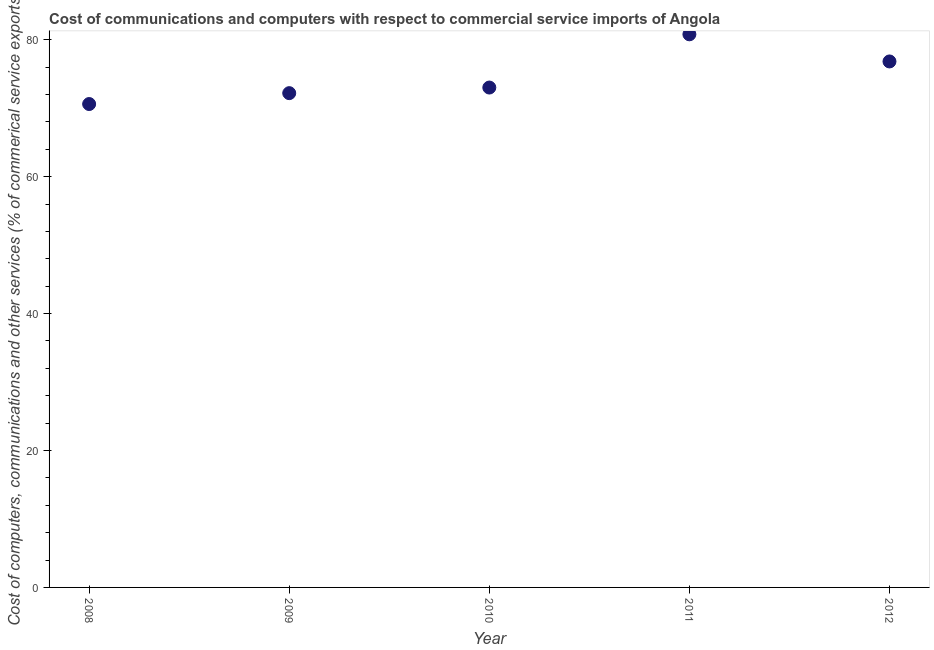What is the  computer and other services in 2009?
Make the answer very short. 72.2. Across all years, what is the maximum cost of communications?
Your answer should be compact. 80.8. Across all years, what is the minimum  computer and other services?
Your answer should be very brief. 70.61. In which year was the  computer and other services maximum?
Your answer should be very brief. 2011. In which year was the  computer and other services minimum?
Give a very brief answer. 2008. What is the sum of the cost of communications?
Your answer should be compact. 373.47. What is the difference between the cost of communications in 2010 and 2012?
Offer a very short reply. -3.81. What is the average  computer and other services per year?
Keep it short and to the point. 74.69. What is the median  computer and other services?
Provide a short and direct response. 73.02. In how many years, is the cost of communications greater than 40 %?
Make the answer very short. 5. What is the ratio of the cost of communications in 2010 to that in 2012?
Your answer should be very brief. 0.95. What is the difference between the highest and the second highest  computer and other services?
Ensure brevity in your answer.  3.96. What is the difference between the highest and the lowest  computer and other services?
Your answer should be very brief. 10.18. In how many years, is the  computer and other services greater than the average  computer and other services taken over all years?
Your answer should be compact. 2. Does the  computer and other services monotonically increase over the years?
Provide a short and direct response. No. How many dotlines are there?
Ensure brevity in your answer.  1. Does the graph contain grids?
Offer a terse response. No. What is the title of the graph?
Offer a very short reply. Cost of communications and computers with respect to commercial service imports of Angola. What is the label or title of the Y-axis?
Provide a short and direct response. Cost of computers, communications and other services (% of commerical service exports). What is the Cost of computers, communications and other services (% of commerical service exports) in 2008?
Offer a very short reply. 70.61. What is the Cost of computers, communications and other services (% of commerical service exports) in 2009?
Your answer should be compact. 72.2. What is the Cost of computers, communications and other services (% of commerical service exports) in 2010?
Your response must be concise. 73.02. What is the Cost of computers, communications and other services (% of commerical service exports) in 2011?
Provide a succinct answer. 80.8. What is the Cost of computers, communications and other services (% of commerical service exports) in 2012?
Provide a succinct answer. 76.83. What is the difference between the Cost of computers, communications and other services (% of commerical service exports) in 2008 and 2009?
Ensure brevity in your answer.  -1.59. What is the difference between the Cost of computers, communications and other services (% of commerical service exports) in 2008 and 2010?
Your response must be concise. -2.41. What is the difference between the Cost of computers, communications and other services (% of commerical service exports) in 2008 and 2011?
Your answer should be compact. -10.18. What is the difference between the Cost of computers, communications and other services (% of commerical service exports) in 2008 and 2012?
Offer a terse response. -6.22. What is the difference between the Cost of computers, communications and other services (% of commerical service exports) in 2009 and 2010?
Provide a short and direct response. -0.82. What is the difference between the Cost of computers, communications and other services (% of commerical service exports) in 2009 and 2011?
Your response must be concise. -8.6. What is the difference between the Cost of computers, communications and other services (% of commerical service exports) in 2009 and 2012?
Provide a short and direct response. -4.63. What is the difference between the Cost of computers, communications and other services (% of commerical service exports) in 2010 and 2011?
Your answer should be very brief. -7.78. What is the difference between the Cost of computers, communications and other services (% of commerical service exports) in 2010 and 2012?
Make the answer very short. -3.81. What is the difference between the Cost of computers, communications and other services (% of commerical service exports) in 2011 and 2012?
Make the answer very short. 3.96. What is the ratio of the Cost of computers, communications and other services (% of commerical service exports) in 2008 to that in 2010?
Offer a terse response. 0.97. What is the ratio of the Cost of computers, communications and other services (% of commerical service exports) in 2008 to that in 2011?
Ensure brevity in your answer.  0.87. What is the ratio of the Cost of computers, communications and other services (% of commerical service exports) in 2008 to that in 2012?
Give a very brief answer. 0.92. What is the ratio of the Cost of computers, communications and other services (% of commerical service exports) in 2009 to that in 2010?
Provide a short and direct response. 0.99. What is the ratio of the Cost of computers, communications and other services (% of commerical service exports) in 2009 to that in 2011?
Give a very brief answer. 0.89. What is the ratio of the Cost of computers, communications and other services (% of commerical service exports) in 2009 to that in 2012?
Offer a terse response. 0.94. What is the ratio of the Cost of computers, communications and other services (% of commerical service exports) in 2010 to that in 2011?
Keep it short and to the point. 0.9. What is the ratio of the Cost of computers, communications and other services (% of commerical service exports) in 2010 to that in 2012?
Provide a short and direct response. 0.95. What is the ratio of the Cost of computers, communications and other services (% of commerical service exports) in 2011 to that in 2012?
Your answer should be very brief. 1.05. 